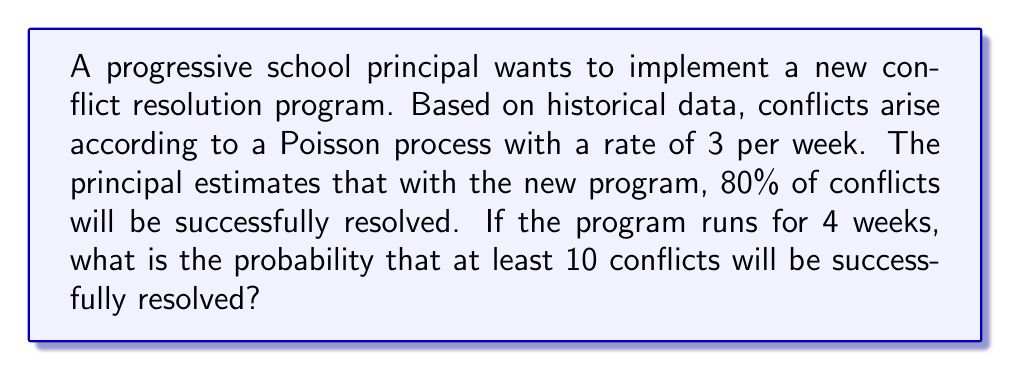Give your solution to this math problem. Let's approach this step-by-step:

1) First, we need to determine the rate of successfully resolved conflicts per week:
   $\lambda_{success} = 3 \times 0.80 = 2.4$ conflicts/week

2) For the entire 4-week period, the rate becomes:
   $\lambda_{total} = 2.4 \times 4 = 9.6$ conflicts

3) We want to find the probability of at least 10 successful resolutions. This is equivalent to finding the probability of not having 0 to 9 successful resolutions and subtracting it from 1.

4) The probability of exactly $k$ events in a Poisson process is given by:

   $$P(X = k) = \frac{e^{-\lambda}\lambda^k}{k!}$$

5) Therefore, the probability of at least 10 successful resolutions is:

   $$P(X \geq 10) = 1 - P(X < 10) = 1 - \sum_{k=0}^9 \frac{e^{-9.6}(9.6)^k}{k!}$$

6) Using a calculator or programming language to compute this sum:

   $$P(X \geq 10) \approx 1 - 0.5578 = 0.4422$$

Thus, the probability of at least 10 conflicts being successfully resolved over the 4-week period is approximately 0.4422 or 44.22%.
Answer: $0.4422$ or $44.22\%$ 